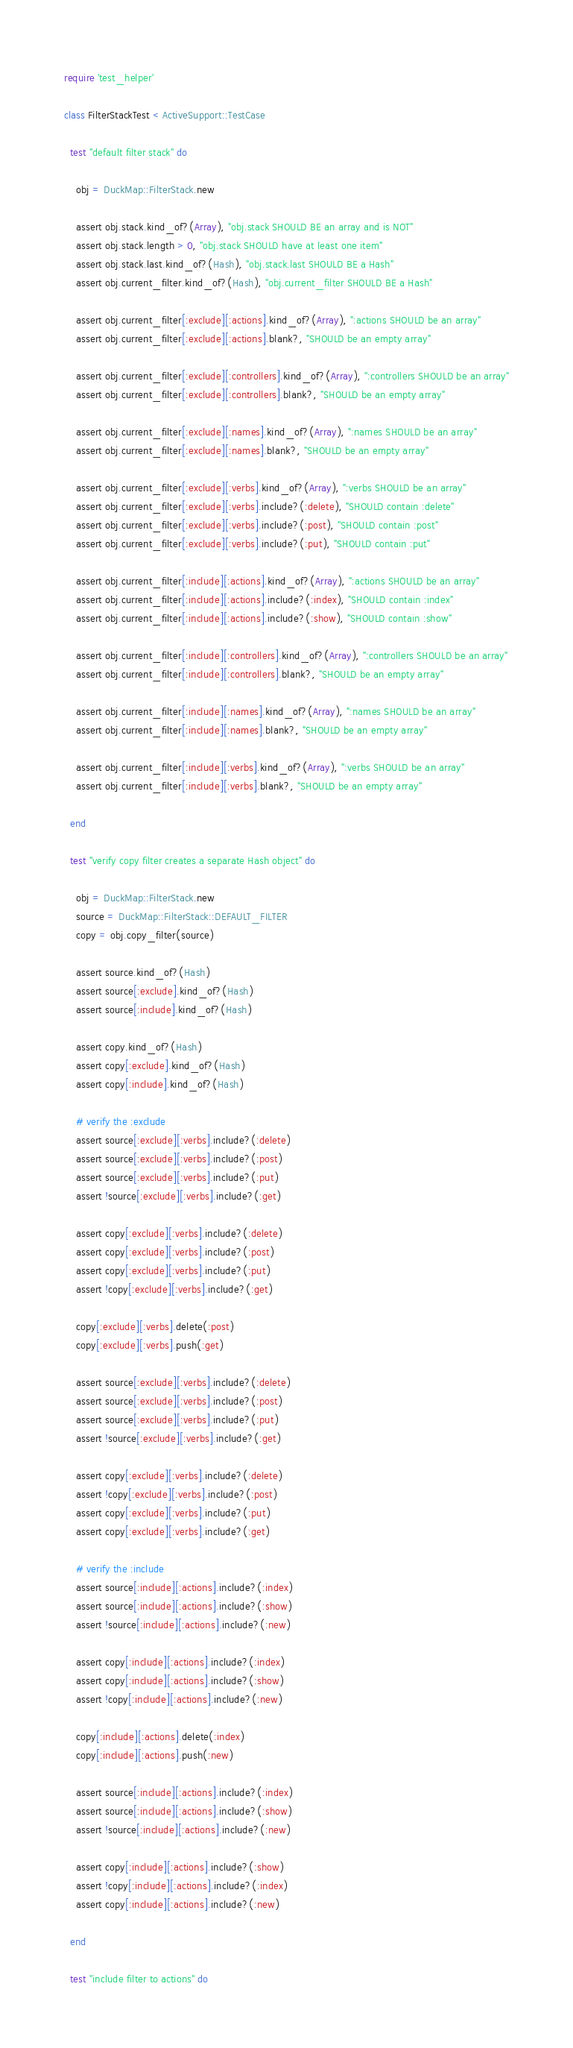<code> <loc_0><loc_0><loc_500><loc_500><_Ruby_>require 'test_helper'

class FilterStackTest < ActiveSupport::TestCase

  test "default filter stack" do

    obj = DuckMap::FilterStack.new

    assert obj.stack.kind_of?(Array), "obj.stack SHOULD BE an array and is NOT"
    assert obj.stack.length > 0, "obj.stack SHOULD have at least one item"
    assert obj.stack.last.kind_of?(Hash), "obj.stack.last SHOULD BE a Hash"
    assert obj.current_filter.kind_of?(Hash), "obj.current_filter SHOULD BE a Hash"

    assert obj.current_filter[:exclude][:actions].kind_of?(Array), ":actions SHOULD be an array"
    assert obj.current_filter[:exclude][:actions].blank?, "SHOULD be an empty array"

    assert obj.current_filter[:exclude][:controllers].kind_of?(Array), ":controllers SHOULD be an array"
    assert obj.current_filter[:exclude][:controllers].blank?, "SHOULD be an empty array"

    assert obj.current_filter[:exclude][:names].kind_of?(Array), ":names SHOULD be an array"
    assert obj.current_filter[:exclude][:names].blank?, "SHOULD be an empty array"

    assert obj.current_filter[:exclude][:verbs].kind_of?(Array), ":verbs SHOULD be an array"
    assert obj.current_filter[:exclude][:verbs].include?(:delete), "SHOULD contain :delete"
    assert obj.current_filter[:exclude][:verbs].include?(:post), "SHOULD contain :post"
    assert obj.current_filter[:exclude][:verbs].include?(:put), "SHOULD contain :put"

    assert obj.current_filter[:include][:actions].kind_of?(Array), ":actions SHOULD be an array"
    assert obj.current_filter[:include][:actions].include?(:index), "SHOULD contain :index"
    assert obj.current_filter[:include][:actions].include?(:show), "SHOULD contain :show"

    assert obj.current_filter[:include][:controllers].kind_of?(Array), ":controllers SHOULD be an array"
    assert obj.current_filter[:include][:controllers].blank?, "SHOULD be an empty array"

    assert obj.current_filter[:include][:names].kind_of?(Array), ":names SHOULD be an array"
    assert obj.current_filter[:include][:names].blank?, "SHOULD be an empty array"

    assert obj.current_filter[:include][:verbs].kind_of?(Array), ":verbs SHOULD be an array"
    assert obj.current_filter[:include][:verbs].blank?, "SHOULD be an empty array"

  end

  test "verify copy filter creates a separate Hash object" do

    obj = DuckMap::FilterStack.new
    source = DuckMap::FilterStack::DEFAULT_FILTER
    copy = obj.copy_filter(source)

    assert source.kind_of?(Hash)
    assert source[:exclude].kind_of?(Hash)
    assert source[:include].kind_of?(Hash)

    assert copy.kind_of?(Hash)
    assert copy[:exclude].kind_of?(Hash)
    assert copy[:include].kind_of?(Hash)

    # verify the :exclude
    assert source[:exclude][:verbs].include?(:delete)
    assert source[:exclude][:verbs].include?(:post)
    assert source[:exclude][:verbs].include?(:put)
    assert !source[:exclude][:verbs].include?(:get)

    assert copy[:exclude][:verbs].include?(:delete)
    assert copy[:exclude][:verbs].include?(:post)
    assert copy[:exclude][:verbs].include?(:put)
    assert !copy[:exclude][:verbs].include?(:get)

    copy[:exclude][:verbs].delete(:post)
    copy[:exclude][:verbs].push(:get)

    assert source[:exclude][:verbs].include?(:delete)
    assert source[:exclude][:verbs].include?(:post)
    assert source[:exclude][:verbs].include?(:put)
    assert !source[:exclude][:verbs].include?(:get)

    assert copy[:exclude][:verbs].include?(:delete)
    assert !copy[:exclude][:verbs].include?(:post)
    assert copy[:exclude][:verbs].include?(:put)
    assert copy[:exclude][:verbs].include?(:get)

    # verify the :include
    assert source[:include][:actions].include?(:index)
    assert source[:include][:actions].include?(:show)
    assert !source[:include][:actions].include?(:new)

    assert copy[:include][:actions].include?(:index)
    assert copy[:include][:actions].include?(:show)
    assert !copy[:include][:actions].include?(:new)

    copy[:include][:actions].delete(:index)
    copy[:include][:actions].push(:new)

    assert source[:include][:actions].include?(:index)
    assert source[:include][:actions].include?(:show)
    assert !source[:include][:actions].include?(:new)

    assert copy[:include][:actions].include?(:show)
    assert !copy[:include][:actions].include?(:index)
    assert copy[:include][:actions].include?(:new)

  end

  test "include filter to actions" do
</code> 